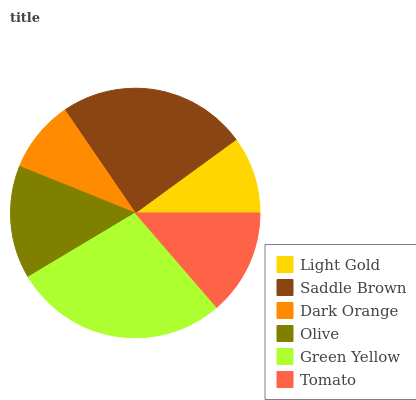Is Dark Orange the minimum?
Answer yes or no. Yes. Is Green Yellow the maximum?
Answer yes or no. Yes. Is Saddle Brown the minimum?
Answer yes or no. No. Is Saddle Brown the maximum?
Answer yes or no. No. Is Saddle Brown greater than Light Gold?
Answer yes or no. Yes. Is Light Gold less than Saddle Brown?
Answer yes or no. Yes. Is Light Gold greater than Saddle Brown?
Answer yes or no. No. Is Saddle Brown less than Light Gold?
Answer yes or no. No. Is Olive the high median?
Answer yes or no. Yes. Is Tomato the low median?
Answer yes or no. Yes. Is Tomato the high median?
Answer yes or no. No. Is Dark Orange the low median?
Answer yes or no. No. 